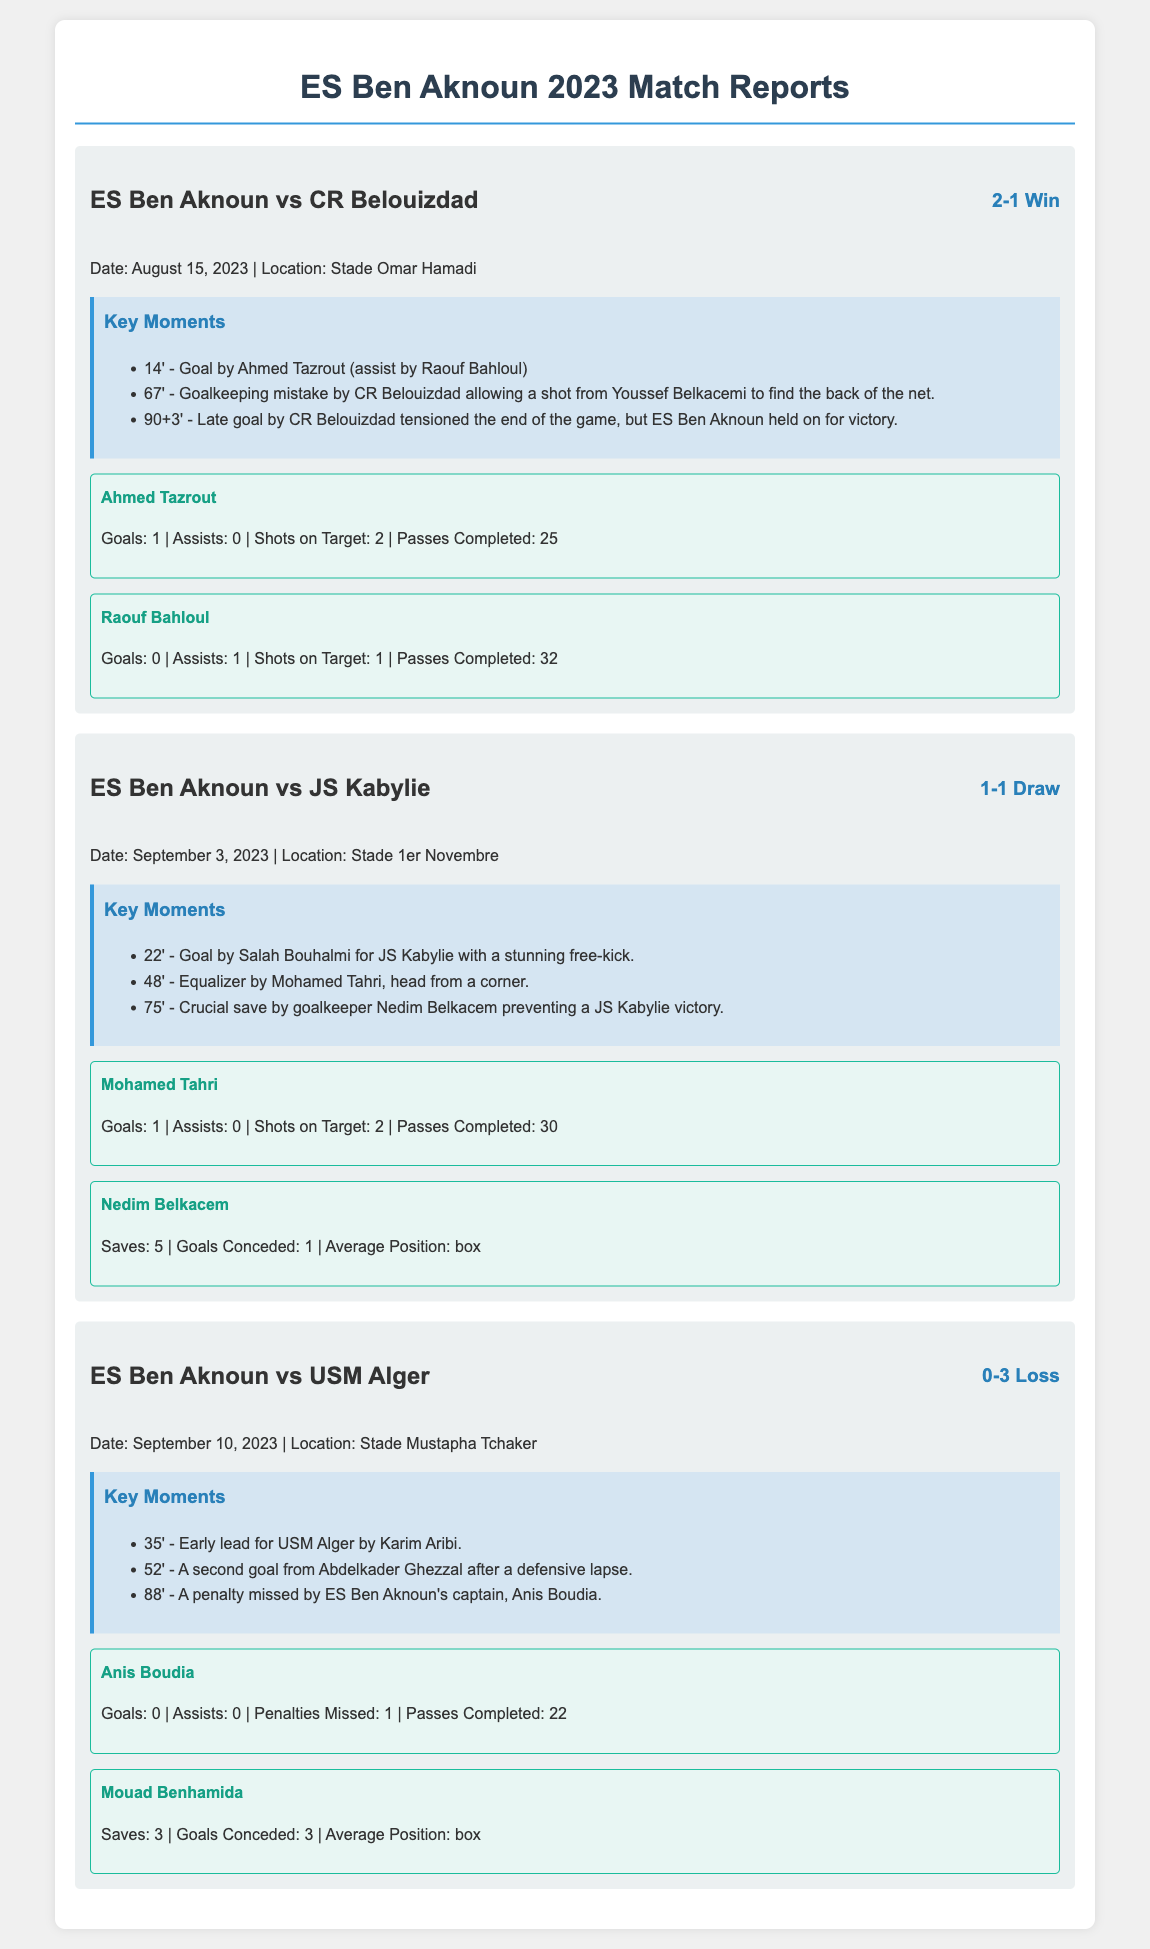What was the final score of the match against CR Belouizdad? The final score is mentioned in the match report against CR Belouizdad, which is a 2-1 win for ES Ben Aknoun.
Answer: 2-1 Win Who scored the equalizing goal against JS Kabylie? The player who scored the equalizing goal is mentioned, which is Mohamed Tahri.
Answer: Mohamed Tahri How many goals did Anis Boudia miss penalties for in the match against USM Alger? The match report states that Anis Boudia missed 1 penalty during the match against USM Alger.
Answer: 1 What time was the first goal scored by Ahmed Tazrout? The time of the first goal scored by Ahmed Tazrout is listed as 14 minutes into the match against CR Belouizdad.
Answer: 14' How many saves did Nedim Belkacem make in the draw against JS Kabylie? The document states that Nedim Belkacem made 5 saves during the match against JS Kabylie.
Answer: 5 How many goals did ES Ben Aknoun concede against USM Alger? The document indicates that ES Ben Aknoun conceded 3 goals in the match against USM Alger.
Answer: 3 What year are these match reports for ES Ben Aknoun? The match reports specifically mention the year 2023 for ES Ben Aknoun's games.
Answer: 2023 What was the location of the match against JS Kabylie? The location of the match against JS Kabylie is stated as Stade 1er Novembre in the report.
Answer: Stade 1er Novembre 